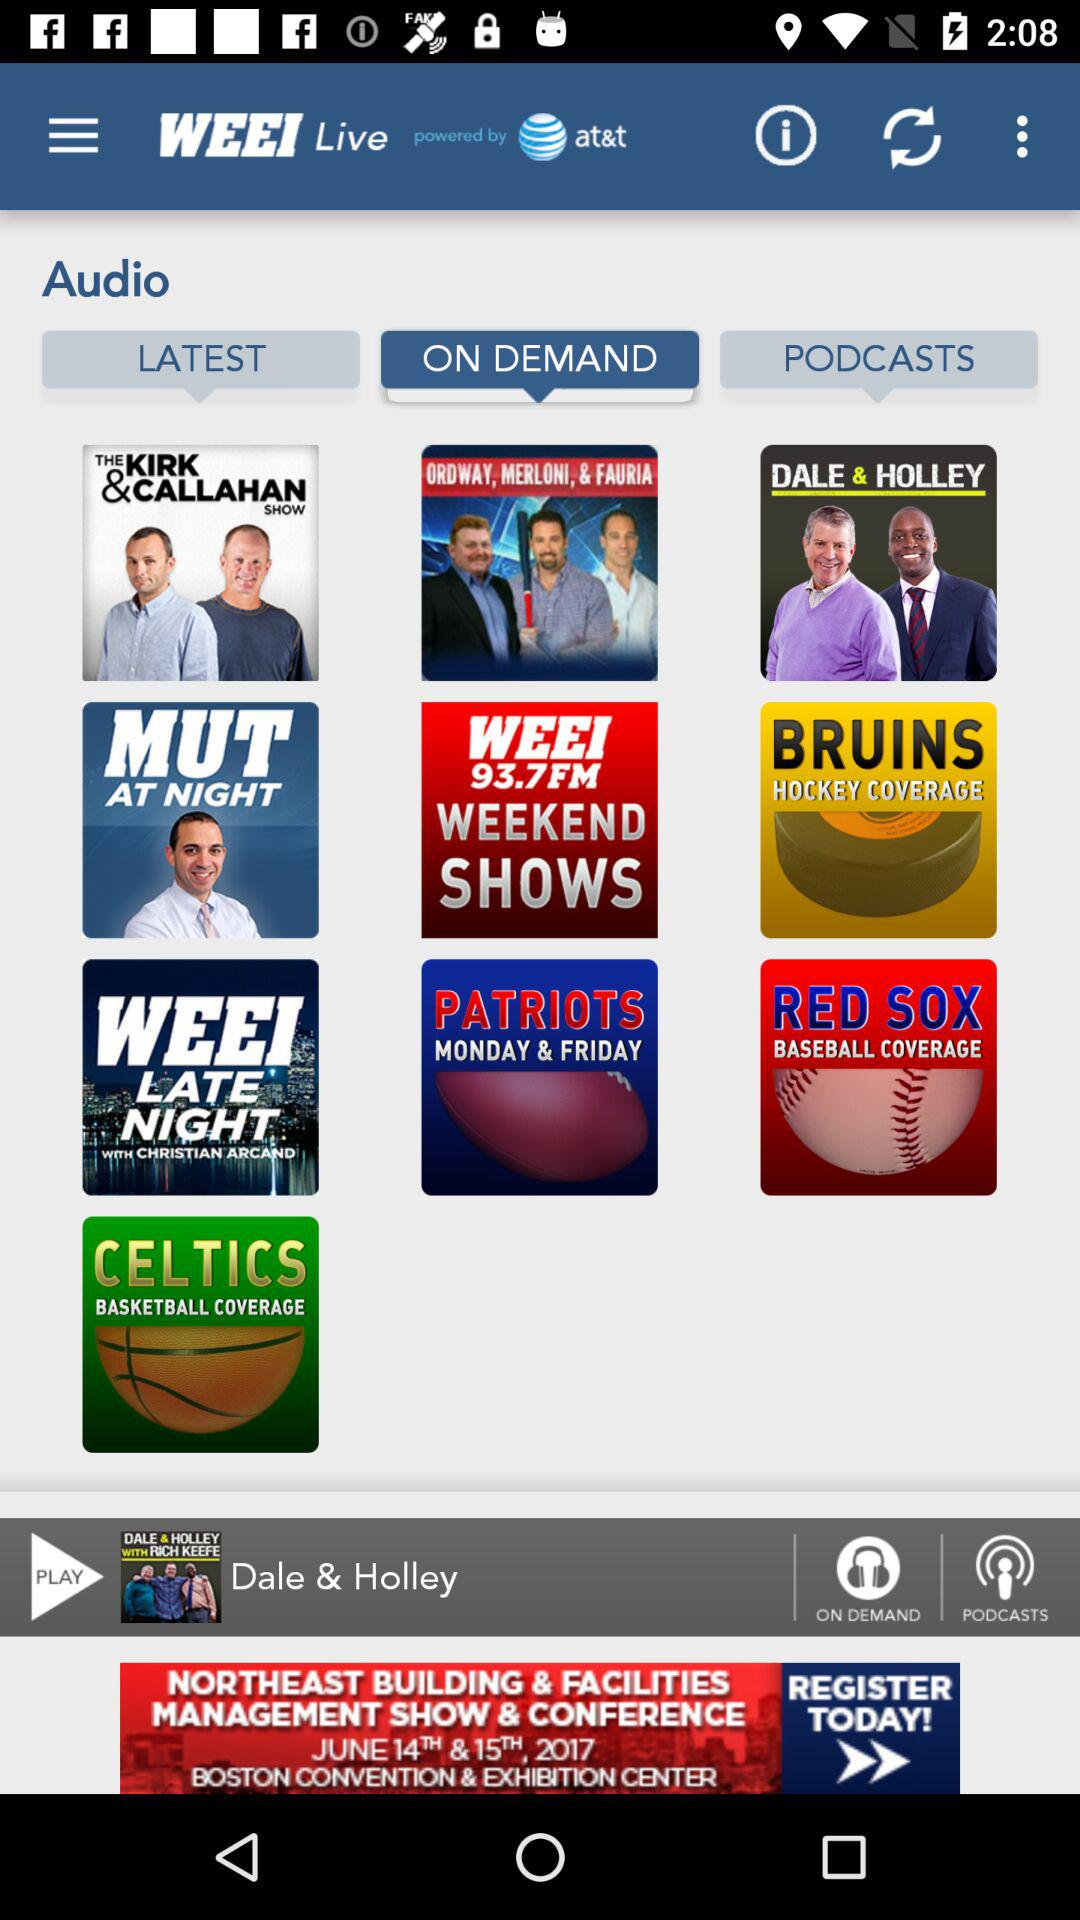Which audio was last played? The last played audio was "Dale & Holley". 